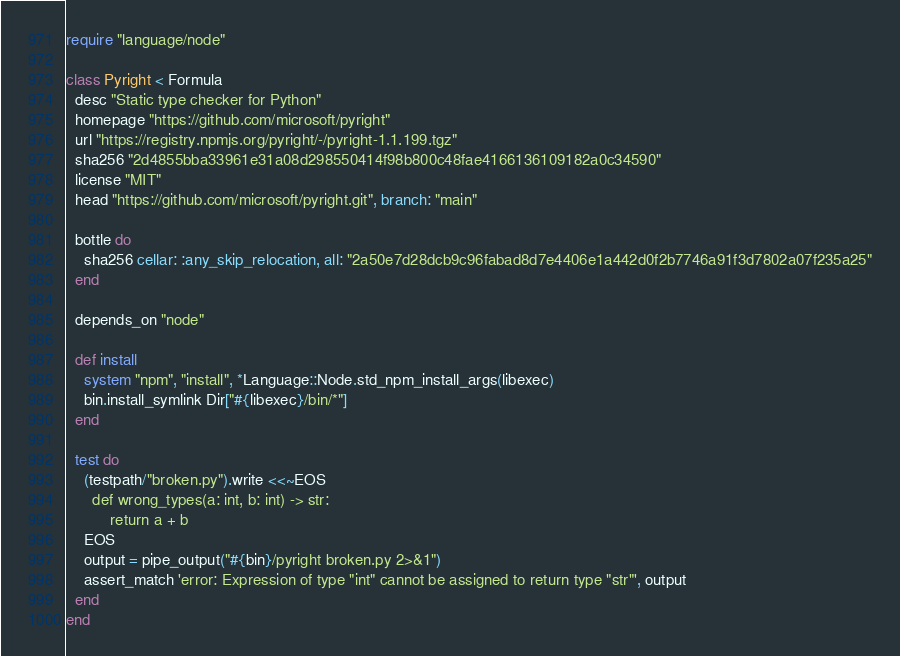<code> <loc_0><loc_0><loc_500><loc_500><_Ruby_>require "language/node"

class Pyright < Formula
  desc "Static type checker for Python"
  homepage "https://github.com/microsoft/pyright"
  url "https://registry.npmjs.org/pyright/-/pyright-1.1.199.tgz"
  sha256 "2d4855bba33961e31a08d298550414f98b800c48fae4166136109182a0c34590"
  license "MIT"
  head "https://github.com/microsoft/pyright.git", branch: "main"

  bottle do
    sha256 cellar: :any_skip_relocation, all: "2a50e7d28dcb9c96fabad8d7e4406e1a442d0f2b7746a91f3d7802a07f235a25"
  end

  depends_on "node"

  def install
    system "npm", "install", *Language::Node.std_npm_install_args(libexec)
    bin.install_symlink Dir["#{libexec}/bin/*"]
  end

  test do
    (testpath/"broken.py").write <<~EOS
      def wrong_types(a: int, b: int) -> str:
          return a + b
    EOS
    output = pipe_output("#{bin}/pyright broken.py 2>&1")
    assert_match 'error: Expression of type "int" cannot be assigned to return type "str"', output
  end
end
</code> 